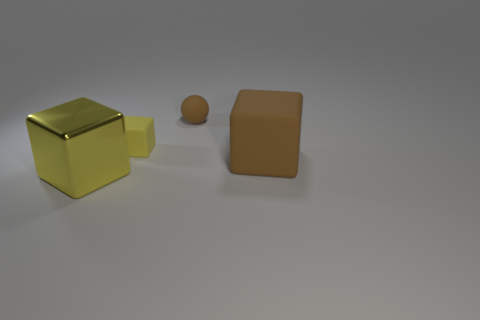Is there anything else that has the same material as the large brown thing?
Ensure brevity in your answer.  Yes. Are there any large rubber objects on the left side of the yellow metal block?
Provide a short and direct response. No. What color is the rubber thing that is both on the right side of the tiny yellow matte thing and in front of the tiny sphere?
Give a very brief answer. Brown. What is the shape of the large rubber object that is the same color as the small ball?
Offer a very short reply. Cube. There is a brown object that is behind the small matte object that is to the left of the sphere; what size is it?
Provide a succinct answer. Small. What number of balls are gray metallic things or matte things?
Your answer should be very brief. 1. There is a rubber ball that is the same size as the yellow rubber object; what is its color?
Give a very brief answer. Brown. What is the shape of the brown thing that is behind the big thing behind the metal object?
Offer a very short reply. Sphere. There is a metal object in front of the yellow matte object; does it have the same size as the brown cube?
Your answer should be compact. Yes. How many other objects are there of the same material as the big yellow block?
Provide a short and direct response. 0. 